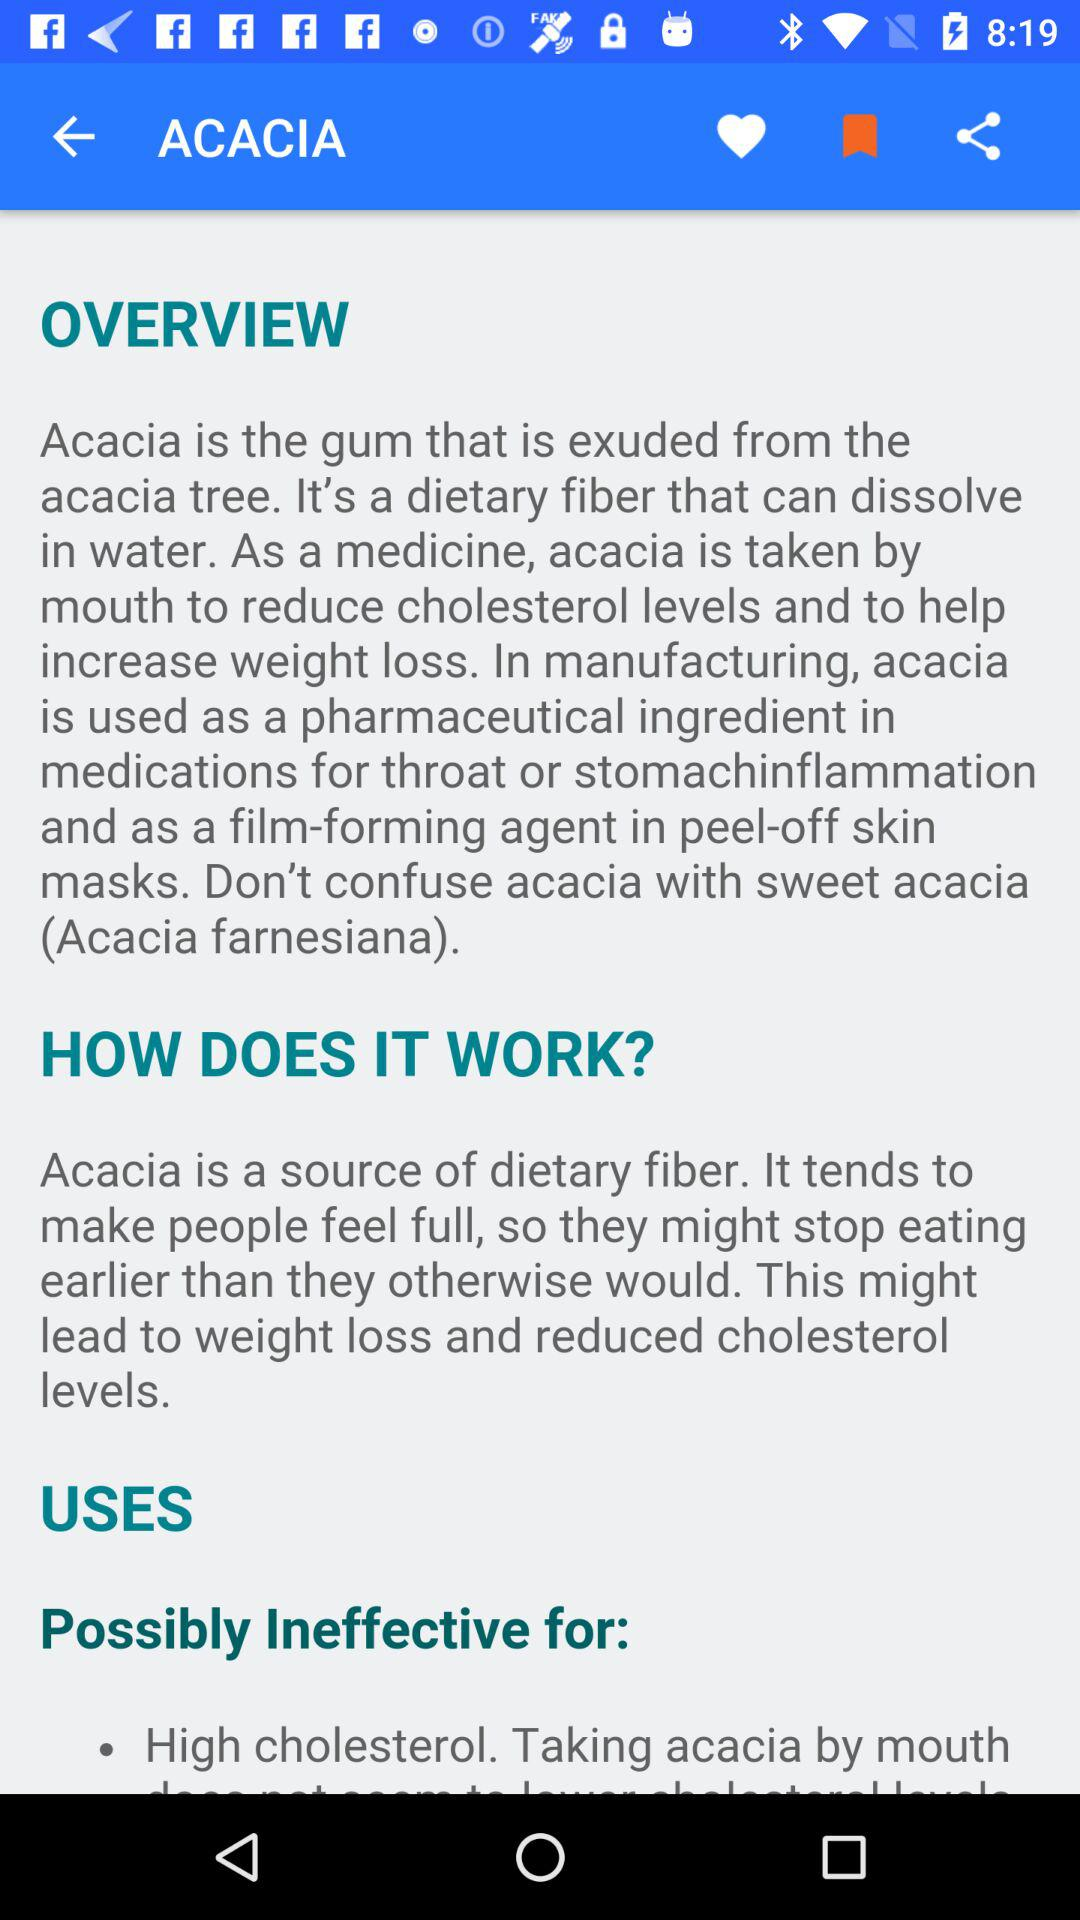How can acacia be used in the manufacturing process? Acacia can be used as a pharmaceutical ingredient in medications for throat or stomach inflammation and as a film-forming agent in peel-off skin masks. 